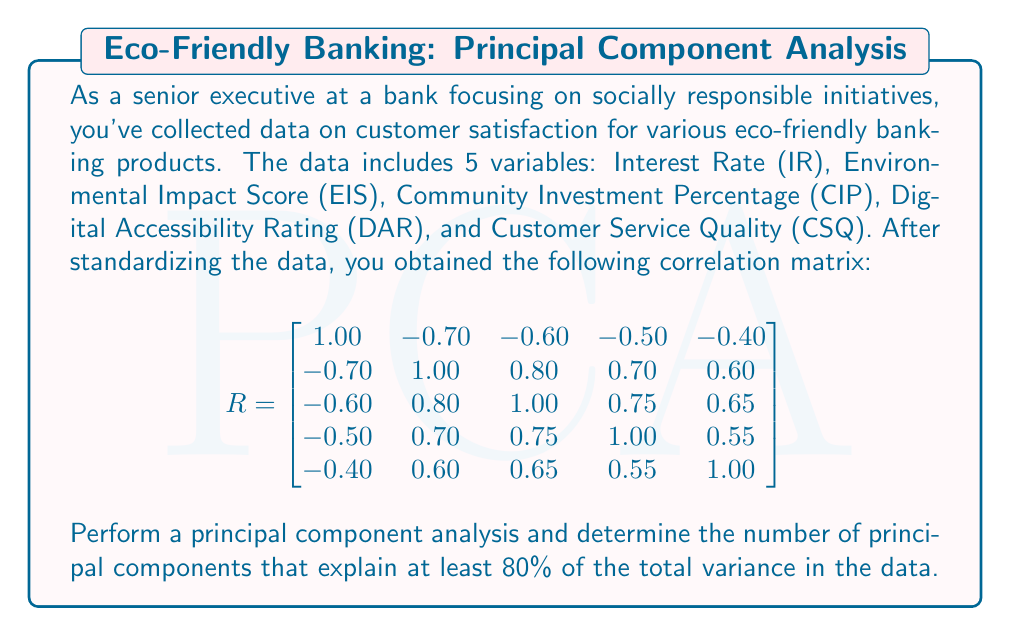Show me your answer to this math problem. To perform the principal component analysis and determine the number of principal components explaining at least 80% of the total variance, we'll follow these steps:

1) Calculate the eigenvalues and eigenvectors of the correlation matrix R.

2) The eigenvalues represent the amount of variance explained by each principal component. We'll sort them in descending order.

3) Calculate the proportion of variance explained by each component and the cumulative proportion.

4) Determine how many components are needed to reach at least 80% cumulative explained variance.

Step 1: Calculate eigenvalues
Using a mathematical software or calculator, we find the eigenvalues of R:

$\lambda_1 = 3.7245$
$\lambda_2 = 0.7328$
$\lambda_3 = 0.2851$
$\lambda_4 = 0.1576$
$\lambda_5 = 0.1000$

Step 2: Sort eigenvalues (already in descending order)

Step 3: Calculate proportion and cumulative proportion of variance

Total variance = sum of eigenvalues = 5 (since it's a correlation matrix)

Proportion of variance for each component:
$P_1 = 3.7245 / 5 = 0.7449$ or 74.49%
$P_2 = 0.7328 / 5 = 0.1466$ or 14.66%
$P_3 = 0.2851 / 5 = 0.0570$ or 5.70%
$P_4 = 0.1576 / 5 = 0.0315$ or 3.15%
$P_5 = 0.1000 / 5 = 0.0200$ or 2.00%

Cumulative proportion:
$C_1 = 0.7449$ or 74.49%
$C_2 = 0.7449 + 0.1466 = 0.8915$ or 89.15%
$C_3 = 0.8915 + 0.0570 = 0.9485$ or 94.85%
$C_4 = 0.9485 + 0.0315 = 0.9800$ or 98.00%
$C_5 = 0.9800 + 0.0200 = 1.0000$ or 100.00%

Step 4: Determine number of components for ≥80% variance
We can see that the first two principal components cumulatively explain 89.15% of the total variance, which exceeds the 80% threshold. The first component alone (74.49%) is not sufficient.

Therefore, we need 2 principal components to explain at least 80% of the total variance in the data.
Answer: 2 principal components 